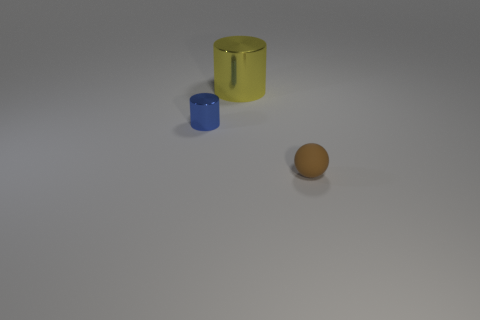Add 3 tiny blue things. How many objects exist? 6 Subtract 0 purple spheres. How many objects are left? 3 Subtract all cylinders. How many objects are left? 1 Subtract all blue shiny cylinders. Subtract all small blue cylinders. How many objects are left? 1 Add 3 small rubber objects. How many small rubber objects are left? 4 Add 2 brown rubber things. How many brown rubber things exist? 3 